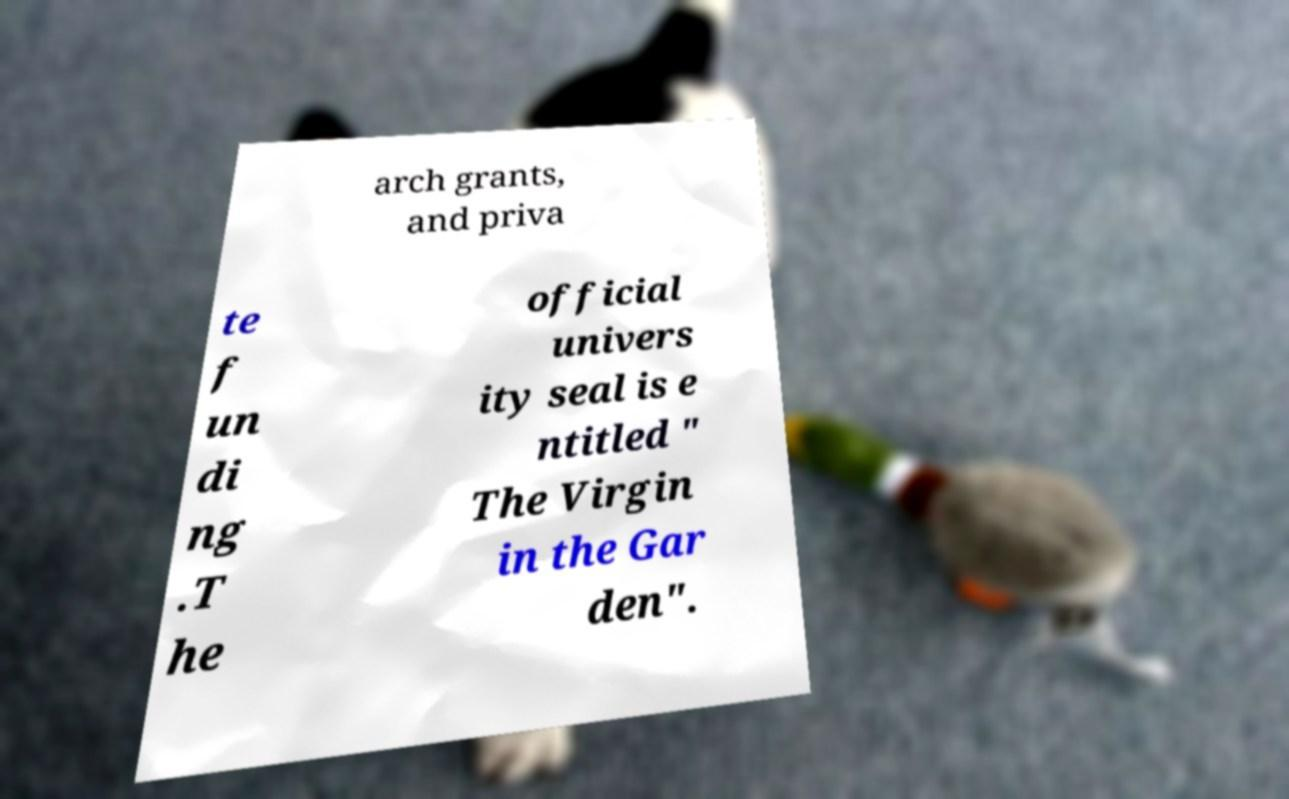There's text embedded in this image that I need extracted. Can you transcribe it verbatim? arch grants, and priva te f un di ng .T he official univers ity seal is e ntitled " The Virgin in the Gar den". 